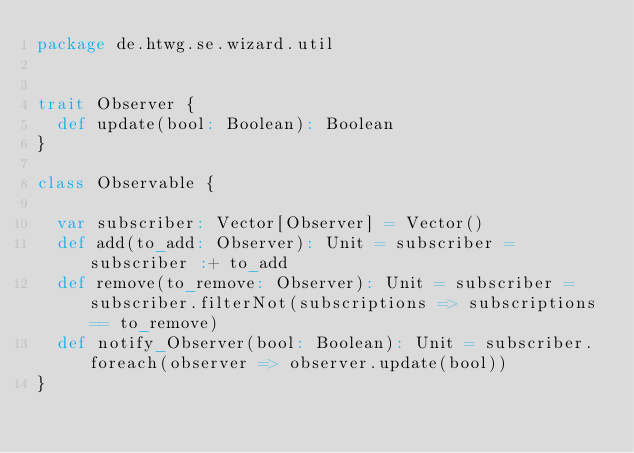Convert code to text. <code><loc_0><loc_0><loc_500><loc_500><_Scala_>package de.htwg.se.wizard.util


trait Observer {
  def update(bool: Boolean): Boolean
}

class Observable {

  var subscriber: Vector[Observer] = Vector()
  def add(to_add: Observer): Unit = subscriber = subscriber :+ to_add
  def remove(to_remove: Observer): Unit = subscriber = subscriber.filterNot(subscriptions => subscriptions == to_remove)
  def notify_Observer(bool: Boolean): Unit = subscriber.foreach(observer => observer.update(bool))
}
</code> 